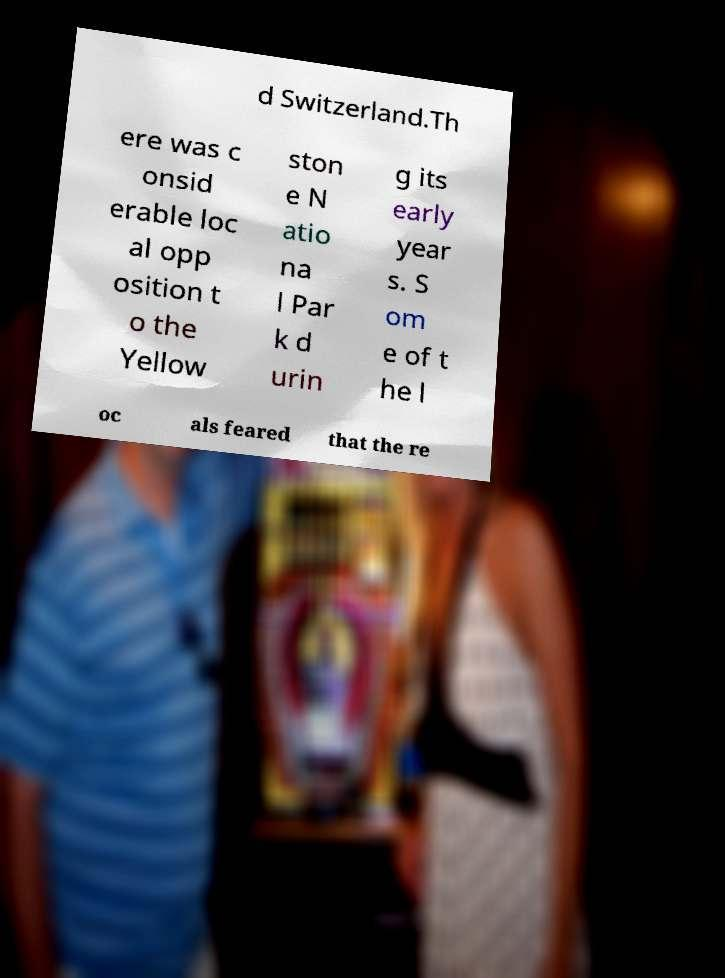What messages or text are displayed in this image? I need them in a readable, typed format. d Switzerland.Th ere was c onsid erable loc al opp osition t o the Yellow ston e N atio na l Par k d urin g its early year s. S om e of t he l oc als feared that the re 